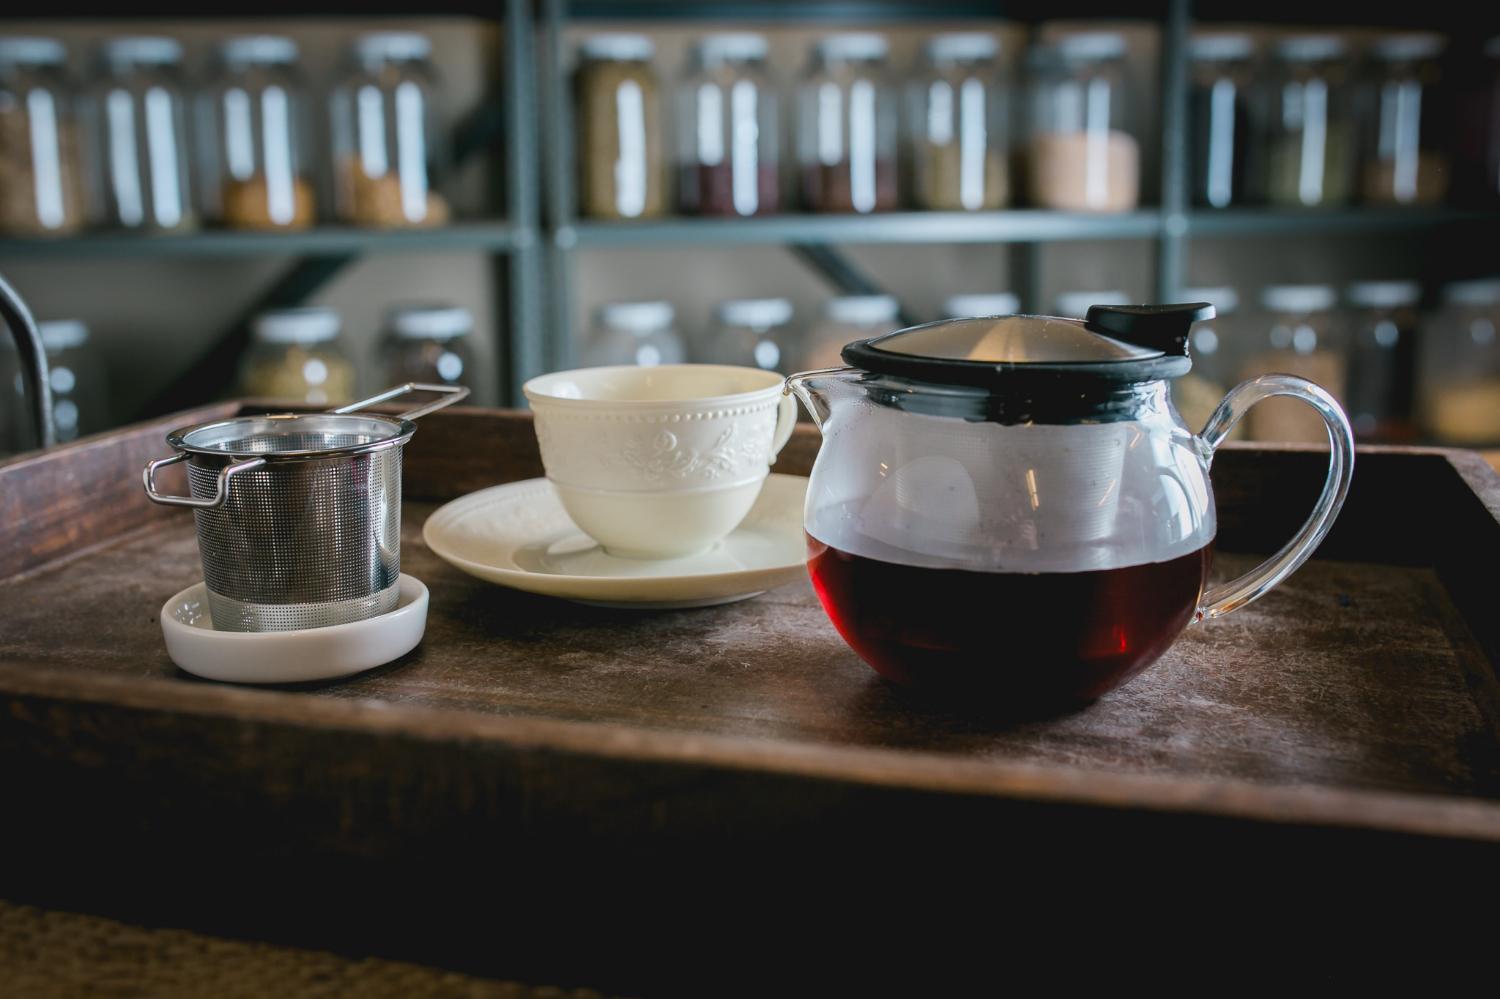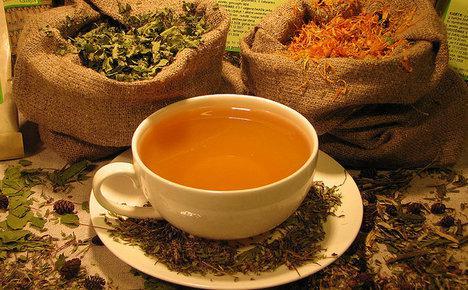The first image is the image on the left, the second image is the image on the right. For the images displayed, is the sentence "The right image includes a porcelain cup with flowers on it sitting on a saucer in front of a container with a spout." factually correct? Answer yes or no. No. The first image is the image on the left, the second image is the image on the right. Evaluate the accuracy of this statement regarding the images: "Any cups in the left image are solid white and any cups in the right image are not solid white.". Is it true? Answer yes or no. No. 